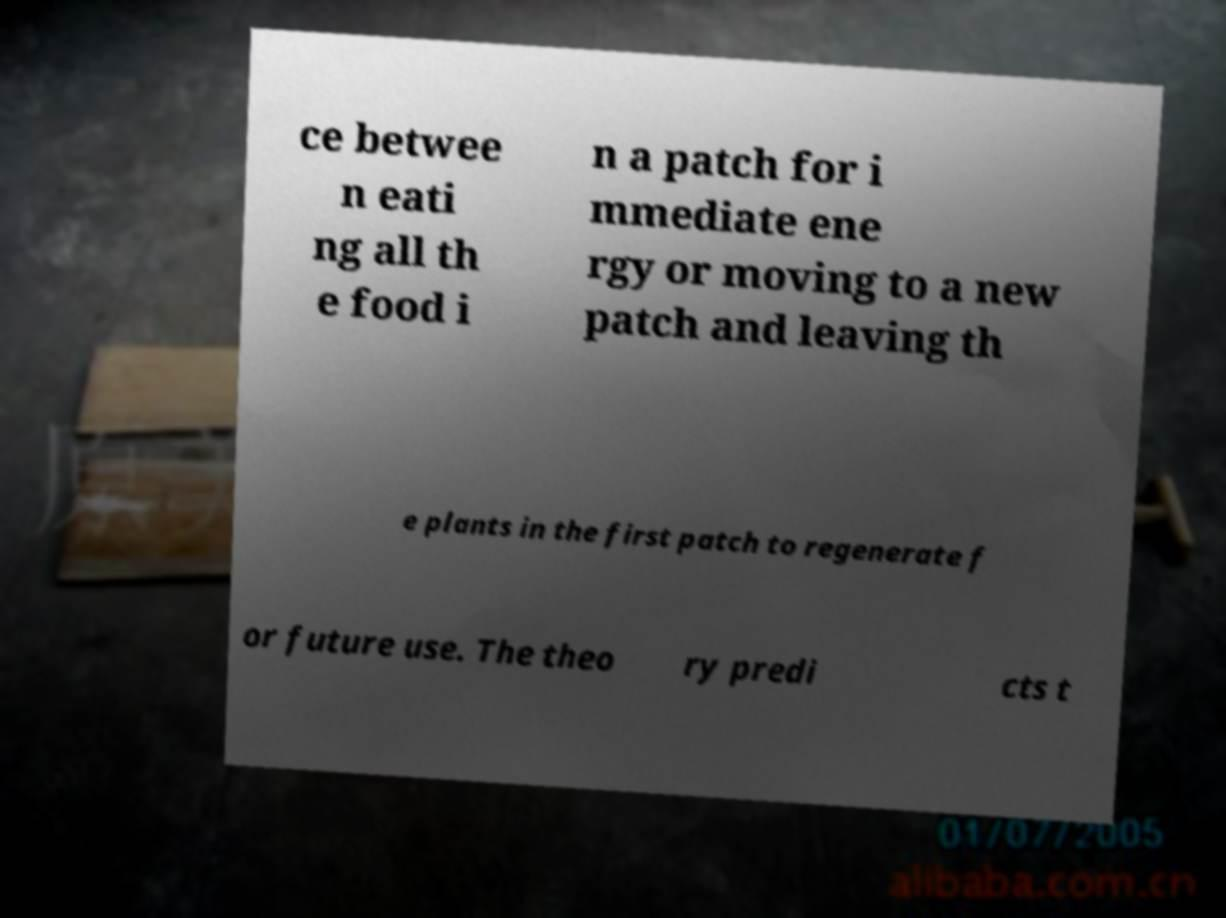Please read and relay the text visible in this image. What does it say? ce betwee n eati ng all th e food i n a patch for i mmediate ene rgy or moving to a new patch and leaving th e plants in the first patch to regenerate f or future use. The theo ry predi cts t 